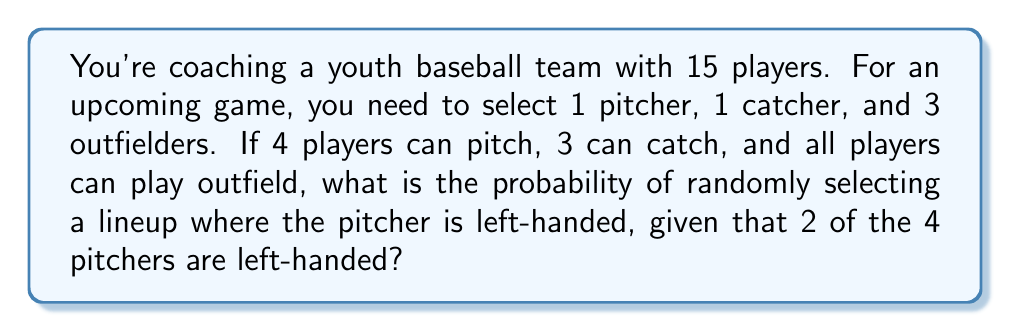Can you solve this math problem? Let's break this down step-by-step:

1) First, we need to calculate the total number of possible lineups:
   - Choose 1 pitcher from 4: $\binom{4}{1}$ = 4
   - Choose 1 catcher from 3: $\binom{3}{1}$ = 3
   - Choose 3 outfielders from remaining 13: $\binom{13}{3}$
   
   Total lineups = $4 \times 3 \times \binom{13}{3}$

2) Now, let's calculate the number of lineups with a left-handed pitcher:
   - Choose 1 left-handed pitcher from 2: $\binom{2}{1}$ = 2
   - Choose 1 catcher from 3: $\binom{3}{1}$ = 3
   - Choose 3 outfielders from remaining 13: $\binom{13}{3}$
   
   Lineups with left-handed pitcher = $2 \times 3 \times \binom{13}{3}$

3) The probability is the number of favorable outcomes divided by the total number of possible outcomes:

   $$P(\text{left-handed pitcher}) = \frac{2 \times 3 \times \binom{13}{3}}{4 \times 3 \times \binom{13}{3}}$$

4) The $3 \times \binom{13}{3}$ cancels out in the numerator and denominator:

   $$P(\text{left-handed pitcher}) = \frac{2}{4} = \frac{1}{2}$$
Answer: $\frac{1}{2}$ or 0.5 or 50% 